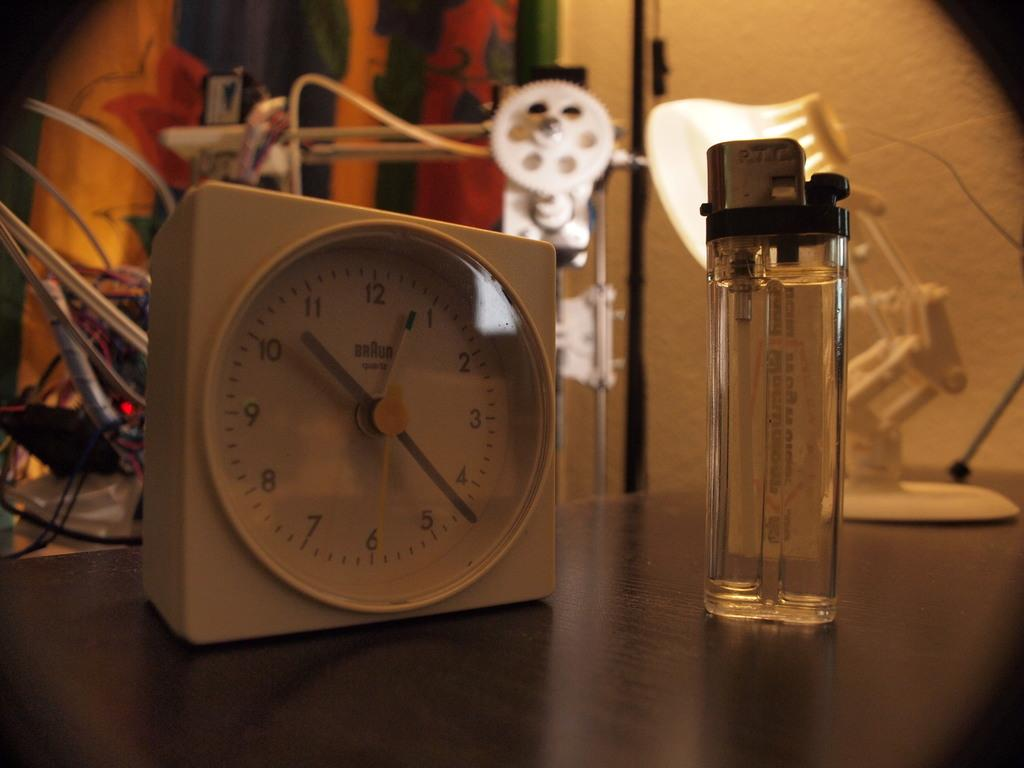Provide a one-sentence caption for the provided image. A Braun Quartz clock sitting next to a lighter. 